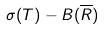<formula> <loc_0><loc_0><loc_500><loc_500>\sigma ( T ) - B ( \overline { R } )</formula> 